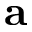Convert formula to latex. <formula><loc_0><loc_0><loc_500><loc_500>a</formula> 